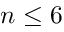<formula> <loc_0><loc_0><loc_500><loc_500>n \leq 6</formula> 